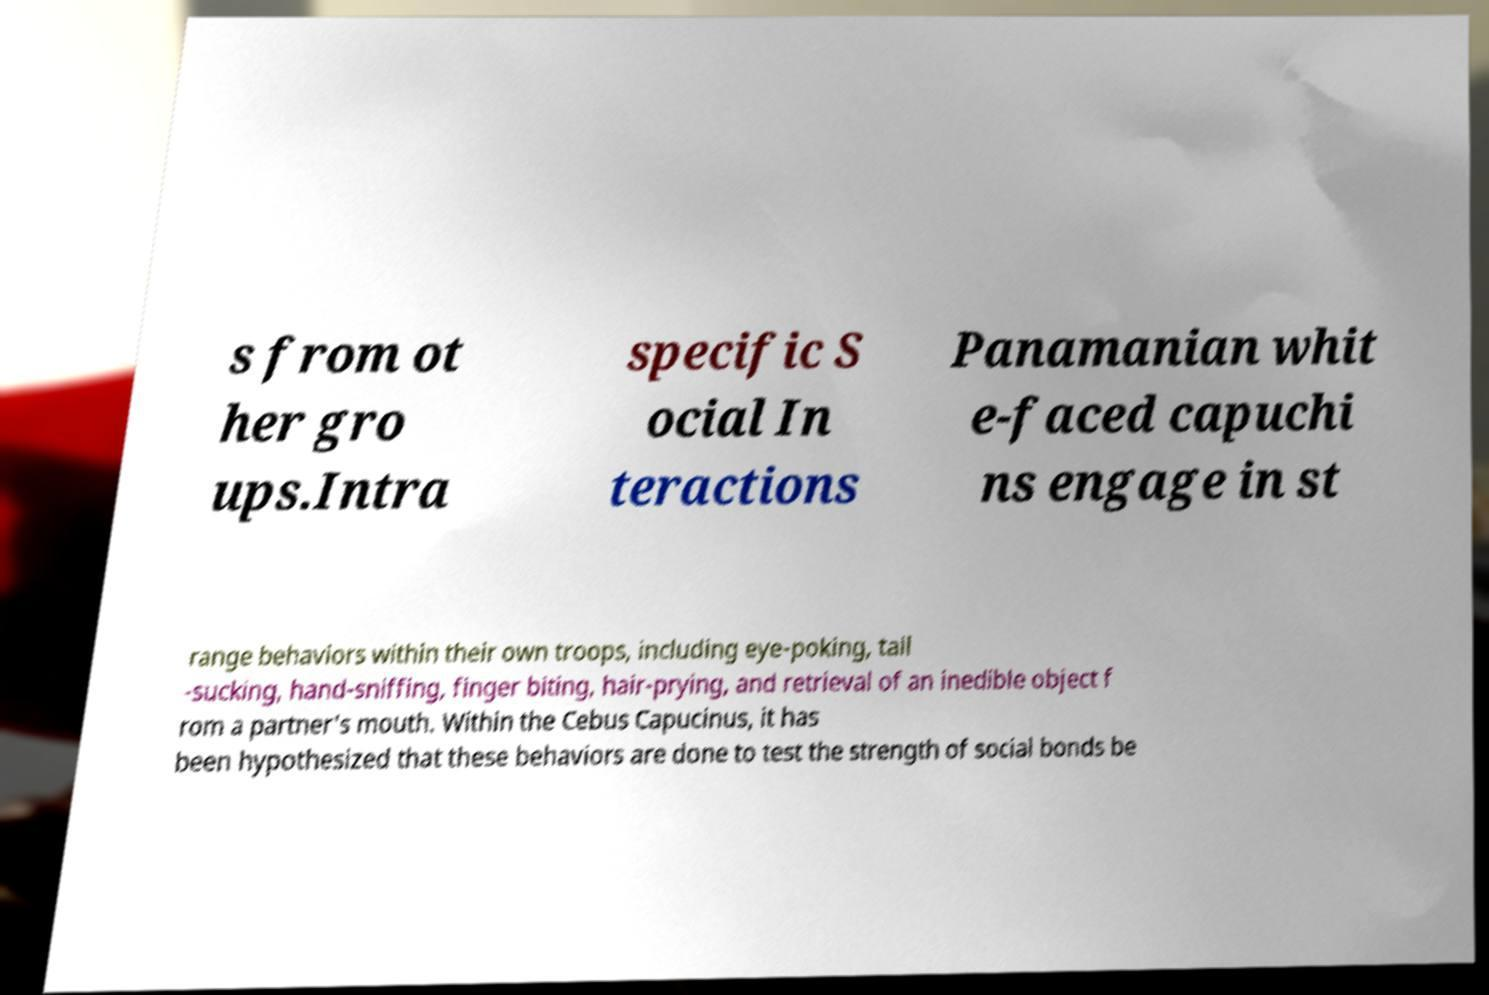Could you assist in decoding the text presented in this image and type it out clearly? s from ot her gro ups.Intra specific S ocial In teractions Panamanian whit e-faced capuchi ns engage in st range behaviors within their own troops, including eye-poking, tail -sucking, hand-sniffing, finger biting, hair-prying, and retrieval of an inedible object f rom a partner's mouth. Within the Cebus Capucinus, it has been hypothesized that these behaviors are done to test the strength of social bonds be 